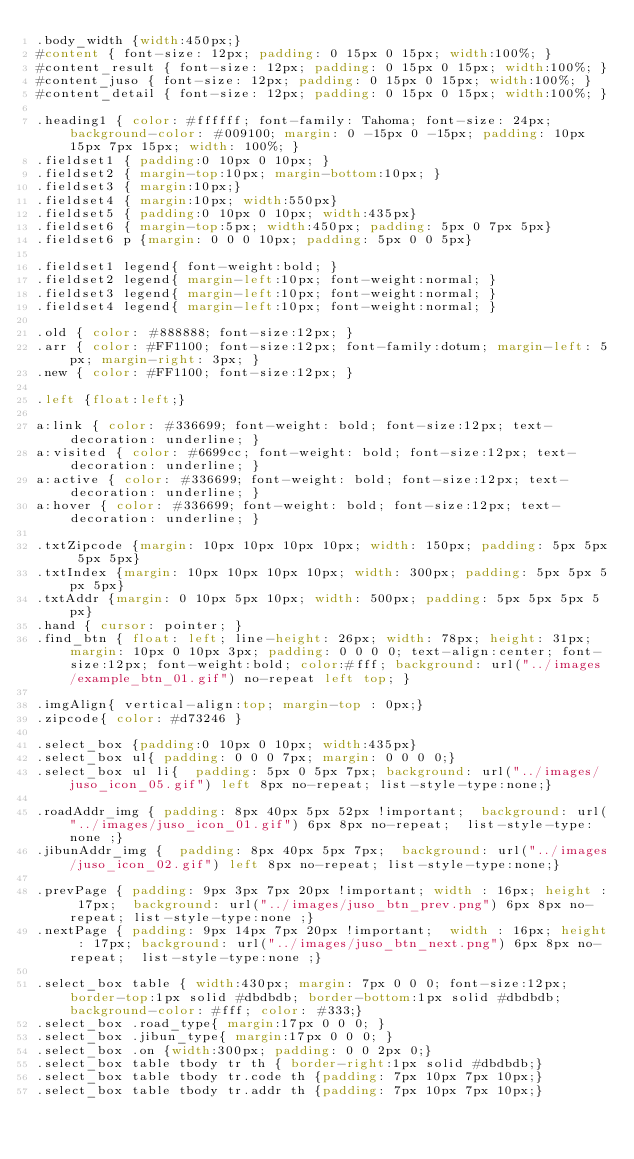Convert code to text. <code><loc_0><loc_0><loc_500><loc_500><_CSS_>.body_width {width:450px;}
#content { font-size: 12px; padding: 0 15px 0 15px; width:100%; }
#content_result { font-size: 12px; padding: 0 15px 0 15px; width:100%; }
#content_juso { font-size: 12px; padding: 0 15px 0 15px; width:100%; }
#content_detail { font-size: 12px; padding: 0 15px 0 15px; width:100%; }

.heading1 { color: #ffffff; font-family: Tahoma; font-size: 24px; background-color: #009100; margin: 0 -15px 0 -15px; padding: 10px 15px 7px 15px; width: 100%; }
.fieldset1 { padding:0 10px 0 10px; }
.fieldset2 { margin-top:10px; margin-bottom:10px; }
.fieldset3 { margin:10px;}
.fieldset4 { margin:10px; width:550px}
.fieldset5 { padding:0 10px 0 10px; width:435px}
.fieldset6 { margin-top:5px; width:450px; padding: 5px 0 7px 5px}
.fieldset6 p {margin: 0 0 0 10px; padding: 5px 0 0 5px}

.fieldset1 legend{ font-weight:bold; }
.fieldset2 legend{ margin-left:10px; font-weight:normal; }
.fieldset3 legend{ margin-left:10px; font-weight:normal; }
.fieldset4 legend{ margin-left:10px; font-weight:normal; }

.old { color: #888888; font-size:12px; }
.arr { color: #FF1100; font-size:12px; font-family:dotum; margin-left: 5px; margin-right: 3px; }
.new { color: #FF1100; font-size:12px; }

.left {float:left;}

a:link { color: #336699; font-weight: bold; font-size:12px; text-decoration: underline; }
a:visited { color: #6699cc; font-weight: bold; font-size:12px; text-decoration: underline; }
a:active { color: #336699; font-weight: bold; font-size:12px; text-decoration: underline; }
a:hover { color: #336699; font-weight: bold; font-size:12px; text-decoration: underline; }

.txtZipcode {margin: 10px 10px 10px 10px; width: 150px; padding: 5px 5px 5px 5px}
.txtIndex {margin: 10px 10px 10px 10px; width: 300px; padding: 5px 5px 5px 5px}
.txtAddr {margin: 0 10px 5px 10px; width: 500px; padding: 5px 5px 5px 5px}
.hand { cursor: pointer; }
.find_btn {	float: left; line-height: 26px; width: 78px; height: 31px; margin: 10px 0 10px 3px; padding: 0 0 0 0; text-align:center; font-size:12px; font-weight:bold; color:#fff; background: url("../images/example_btn_01.gif") no-repeat left top; }

.imgAlign{ vertical-align:top; margin-top : 0px;}
.zipcode{ color: #d73246 }

.select_box {padding:0 10px 0 10px; width:435px}
.select_box ul{	padding: 0 0 0 7px;	margin: 0 0 0 0;}
.select_box ul li{	padding: 5px 0 5px 7px;	background: url("../images/juso_icon_05.gif") left 8px no-repeat; list-style-type:none;}

.roadAddr_img {	padding: 8px 40px 5px 52px !important;	background: url("../images/juso_icon_01.gif") 6px 8px no-repeat;	list-style-type:none ;}
.jibunAddr_img {	padding: 8px 40px 5px 7px;	background: url("../images/juso_icon_02.gif")	left 8px no-repeat;	list-style-type:none;}

.prevPage {	padding: 9px 3px 7px 20px !important; width : 16px; height : 17px;	background: url("../images/juso_btn_prev.png") 6px 8px no-repeat;	list-style-type:none ;}
.nextPage {	padding: 9px 14px 7px 20px !important;	width : 16px; height : 17px; background: url("../images/juso_btn_next.png") 6px 8px no-repeat;	list-style-type:none ;}

.select_box table { width:430px; margin: 7px 0 0 0; font-size:12px; border-top:1px solid #dbdbdb; border-bottom:1px solid #dbdbdb; background-color: #fff; color: #333;}
.select_box .road_type{ margin:17px 0 0 0; }
.select_box .jibun_type{ margin:17px 0 0 0; }
.select_box .on {width:300px; padding: 0 0 2px 0;}
.select_box table tbody tr th { border-right:1px solid #dbdbdb;}
.select_box table tbody tr.code th {padding: 7px 10px 7px 10px;}
.select_box table tbody tr.addr th {padding: 7px 10px 7px 10px;}</code> 